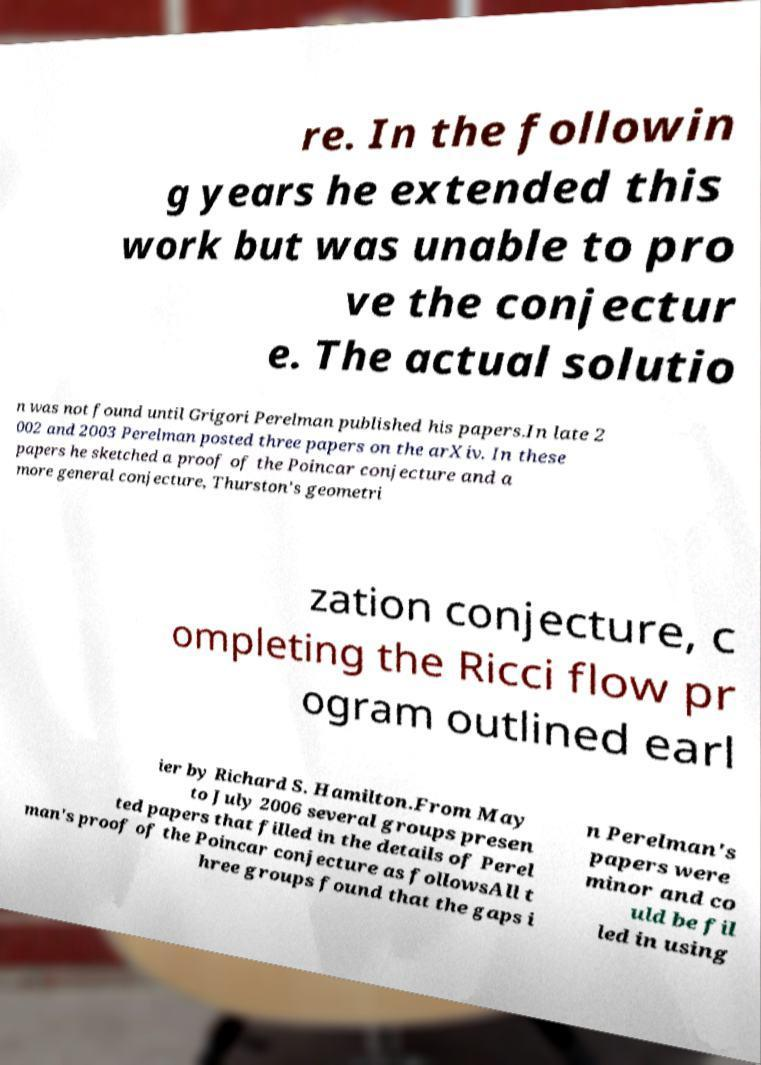There's text embedded in this image that I need extracted. Can you transcribe it verbatim? re. In the followin g years he extended this work but was unable to pro ve the conjectur e. The actual solutio n was not found until Grigori Perelman published his papers.In late 2 002 and 2003 Perelman posted three papers on the arXiv. In these papers he sketched a proof of the Poincar conjecture and a more general conjecture, Thurston's geometri zation conjecture, c ompleting the Ricci flow pr ogram outlined earl ier by Richard S. Hamilton.From May to July 2006 several groups presen ted papers that filled in the details of Perel man's proof of the Poincar conjecture as followsAll t hree groups found that the gaps i n Perelman's papers were minor and co uld be fil led in using 